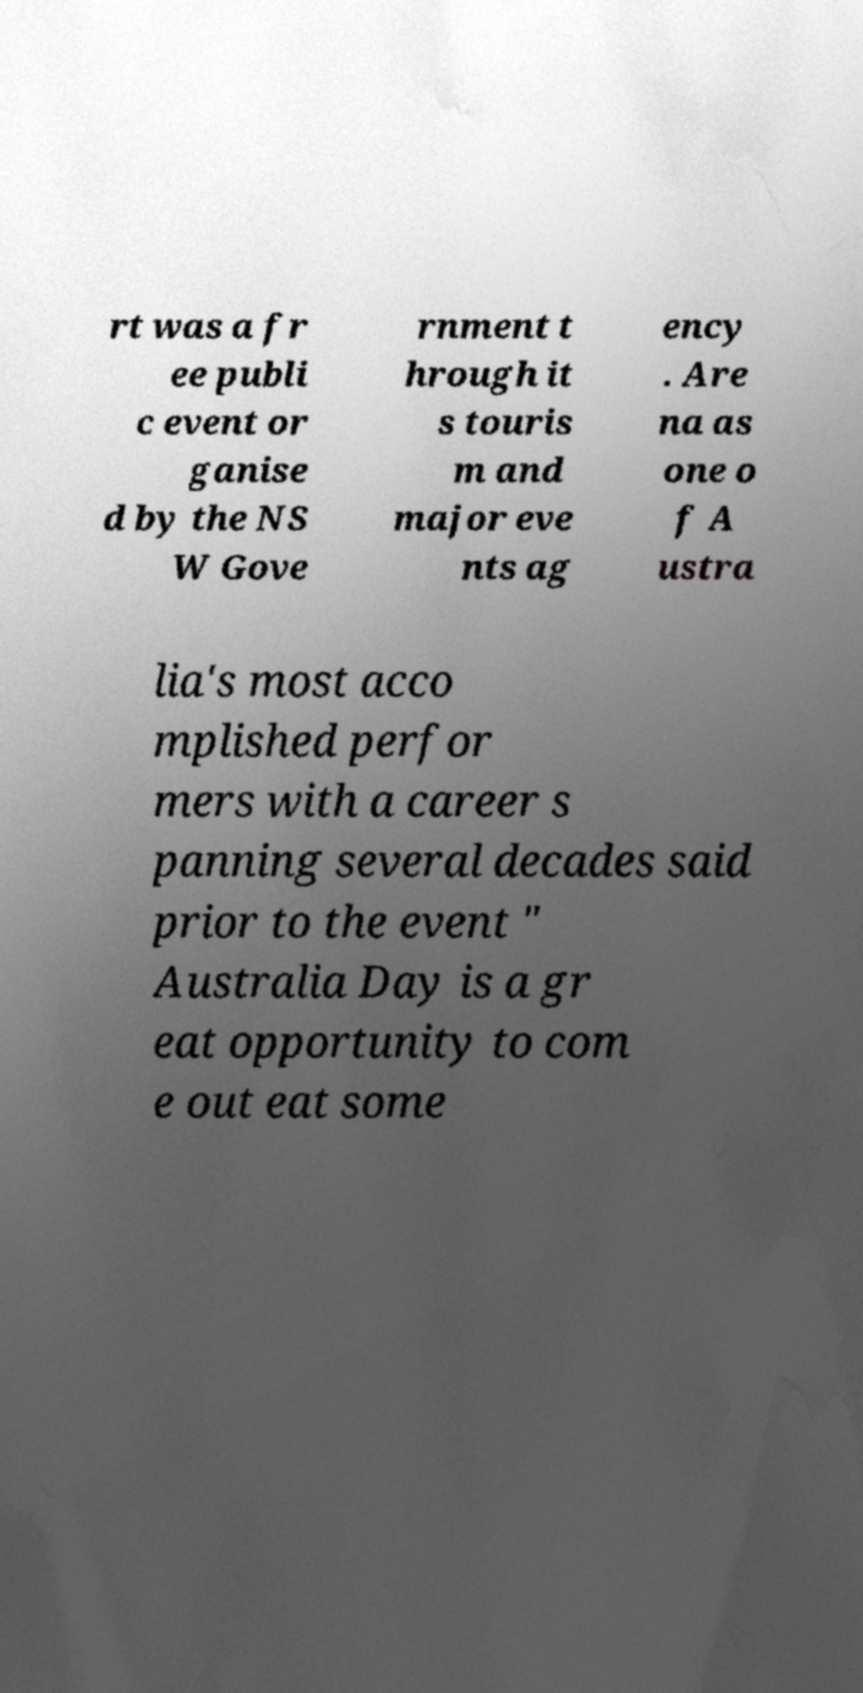There's text embedded in this image that I need extracted. Can you transcribe it verbatim? rt was a fr ee publi c event or ganise d by the NS W Gove rnment t hrough it s touris m and major eve nts ag ency . Are na as one o f A ustra lia's most acco mplished perfor mers with a career s panning several decades said prior to the event " Australia Day is a gr eat opportunity to com e out eat some 